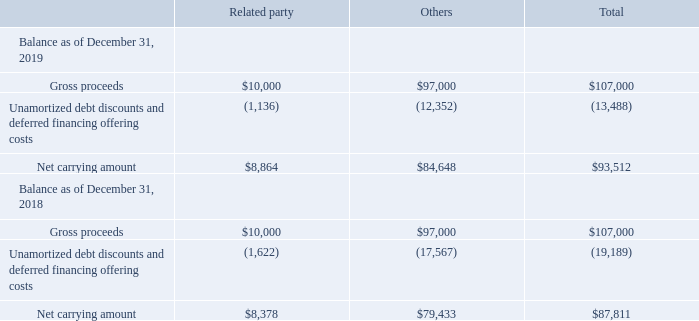Note 12. Convertible Notes
In December 2016, the Company entered into the Purchase Agreement with J.P. Morgan Securities LLC and Jefferies LLC, as representatives of the several initial purchasers named therein (collectively, the “Initial Purchasers”), to issue and sell $90,000 in aggregate principal amount of its 5.50% senior convertible notes due 2021 ("Convertible Notes") in a private placement to qualified institutional buyers pursuant to Rule 144A under the Securities Act of 1933, as amended (the “Securities Act”), and to non-U.S. persons pursuant to Regulation S under the Securities Act. In December 2016, the Company entered into a purchase agreement (the “Cambridge Purchase Agreement”) with Cambridge Equities, L.P. (“Cambridge”), an entity affiliated with Dr. Patrick Soon-Shiong, the Company’s Chairman and Chief Executive Officer, to issue and sell $10,000 in aggregate principal amount of the Convertible Notes in a private placement pursuant to an exemption from the registration requirements of the Securities Act afforded by Section 4(a)(2) of the Securities Act. In December 2016, pursuant to the exercise of the overallotment by the Initial Purchasers, the Company issued an additional $7,000 principal amount of the Convertible Notes. The total net proceeds from this offering were approximately $102,714 ($9,917 from Cambridge and $92,797 from the Initial Purchasers) after deducting the Initial Purchasers’ discount and debt issuance costs of $4,286 in connection with the Convertible Notes offering.
On December 21, 2016, the Company entered into an indenture, relating to the issuance of the Convertible Notes (the “Indenture”), by and between the Company and U.S. Bank National Association, as trustee (the “Trustee”). The interest rates are fixed at 5.50% per year, payable semi- annually on June 15 and December 15 of each year, beginning on June 15, 2017. The Convertible Notes will mature on December 15, 2021, unless earlier repurchased by the Company or converted pursuant to their terms.
In connection with the offering of the Convertible Notes, on December 15, 2016, the Company entered into a Second Amended and Restated Promissory Note which amended and restated the Amended and Restated Promissory Note, dated May 9, 2016, between the Company and NantCapital, to, among other things, extend the maturity date of the Promissory Note to June 15, 2022 and to subordinate such Promissory Note in right of payment to the Convertible Notes (see Note 20).
The initial conversion rate of the Convertible Notes is 82.3893 shares of common stock per $1 principal amount of Convertible Notes (which is equivalent to an initial conversion price of approximately $12.14 per share). Prior to the close of business on the business day immediately preceding September 15, 2021, the Convertible Notes will be convertible only under the following circumstances: (1) during any calendar quarter commencing after March 31, 2017 (and only during such calendar quarter), if, for at least 20 trading days (whether or not consecutive) during the 30 consecutive trading day period ending on the last trading day of the immediately preceding calendar quarter, the last reported sale price of the Company’s common stock on such trading day is greater than or equal to 120% of the conversion price on such trading day; (2) during the five business day period after any five consecutive trading day period in which, for each day of that period, the trading price per $1 principal amount of the Convertible Notes for such trading day was less than 98% of the product of the last reported sale price of the Company’s common stock and the conversion rate on such trading day; or (3) upon the occurrence of specified corporate transactions as described in the Indenture agreement.
Upon conversion, the Convertible Notes will be settled in cash, shares of the Company’s common stock or any combination thereof at the Company’s option.
Upon the occurrence of a fundamental change (as defined in the Indenture), holders may require the Company to purchase all or a portion of the Convertible Notes in principal amounts of $1 or an integral multiple thereof, for cash at a price equal to 100% of the principal amount of the Convertible Notes to be purchased plus any accrued and unpaid interest to, but excluding, the fundamental change purchase date. The conversion rate will be subject to adjustment upon the occurrence of certain specified events.
On or after the date that is one year after the last date of original issuance of the Convertible Notes, if the last reported sale price of the Company’s common stock for at least 20 trading days (whether or not consecutive) during the period of 30 consecutive trading days ending within the five trading days immediately preceding a conversion date is greater than or equal to 120% of the conversion price on each applicable trading day, the Company will make an interest make-whole payment to a converting holder (other than a conversion in connection with a make-whole fundamental change in which the conversion rate is adjusted) equal to the sum of the present values of the scheduled payments of interest that would have been made on the Convertible Notes to be converted had such Convertible Notes remained outstanding from the conversion date through the earlier of (i) the date that is three years after the conversion date and (ii) the maturity date if the Convertible Notes had not been so converted. The present values of the remaining interest payments will be computed using a discount rate equal to 2.0%. The Company may pay any interest make-whole payment either in cash or in shares of its common stock, at the Company’s election as described in the Indenture. On or after the date that is one year after the last date of original issuance of the Convertible Notes, if the last reported sale price of the Company’s common stock for at least 20 trading days (whether or not consecutive) during the period of 30 consecutive trading days ending within the five trading days immediately preceding a conversion date is greater than or equal to 120% of the conversion price on each applicable trading day, the Company will make an interest make-whole payment to a converting holder (other than a conversion in connection with a make-whole fundamental change in which the conversion rate is adjusted) equal to the sum of the present values of the scheduled payments of interest that would have been made on the Convertible Notes to be converted had such Convertible Notes remained outstanding from the conversion date through the earlier of (i) the date that is three years after the conversion date and (ii) the maturity date if the Convertible Notes had not been so converted. The present values of the remaining interest payments will be computed using a discount rate equal to 2.0%. The Company may pay any interest make-whole payment either in cash or in shares of its common stock, at the Company’s election as described in the Indenture.
The Company accounts for convertible debt instruments that may be settled in cash upon conversion (including partial cash settlement) by recording the liability and equity components of the convertible debt separately. The liability component is computed based on the fair value of a similar liability that does not include the conversion option. The liability component includes both the value of the embedded interest make-whole derivative and the carrying value of the Convertible Notes. The equity component is computed based on the total debt proceeds less the fair value of the liability component. The equity component is also recorded as debt discount and amortized as interest expense over the expected term of the Convertible Notes.
The liability component of the Convertible Notes on the date of issuance was computed as $83,079, consisting of the value of the embedded interest make-whole derivative of $1,499 and the carrying value of the Convertible Notes of $81,580. Accordingly, the equity component on the date of issuance was $23,921. If the debt is considered current at the balance sheet date, the liability component of the convertible notes will be classified as current liabilities and presented in current portion of convertible notes debt and the equity component of the convertible debt will be considered a redeemable security and presented as redeemable equity on the Company's Consolidated Balance Sheet.
Offering costs of $4,286 related to the issuance of the Convertible Notes were allocated to the liability and equity components in proportion to the allocation of the proceeds and accounted for as deferred financing offering costs and equity issuance costs, respectively. Approximately $972 of this amount was allocated to equity and the remaining $3,314 was capitalized as deferred financing offering costs.
The debt discounts and deferred financing offering costs on the Convertible Notes are being amortized to interest expense over the contractual terms of the Convertible Notes, using the effective interest method at an effective interest rate of 12.82%.
As of December 31, 2019, the remaining life of the Convertible Notes is approximately 24 months.
The following table summarizes how the issuance of the Convertible Notes is reflected in the Company's Consolidated Balance Sheets as of December 31, 2019 and 2018:
(Dollars in thousands, except per share amounts)
What is the value of the related party gross proceeds as of December 31, 2019?
Answer scale should be: thousand. $10,000. What is the value of other gross proceeds as of December 31, 2019?
Answer scale should be: thousand. $97,000. What is the value of the company's total gross proceeds as of December 31, 2019?
Answer scale should be: thousand. $107,000. What is the value of the company's related party gross proceeds as a percentage of its total gross proceeds in 2019?
Answer scale should be: percent. 10,000/107,000 
Answer: 9.35. What is the average net carrying amount of the company's related party transaction in 2018 and 2019?
Answer scale should be: thousand. (8,864 + 8,378)/2 
Answer: 8621. What is the percentage change in the company's net carrying amount of related party transaction between 2018 and 2019?
Answer scale should be: percent. (8,864 - 8,378)/8,378 
Answer: 5.8. 